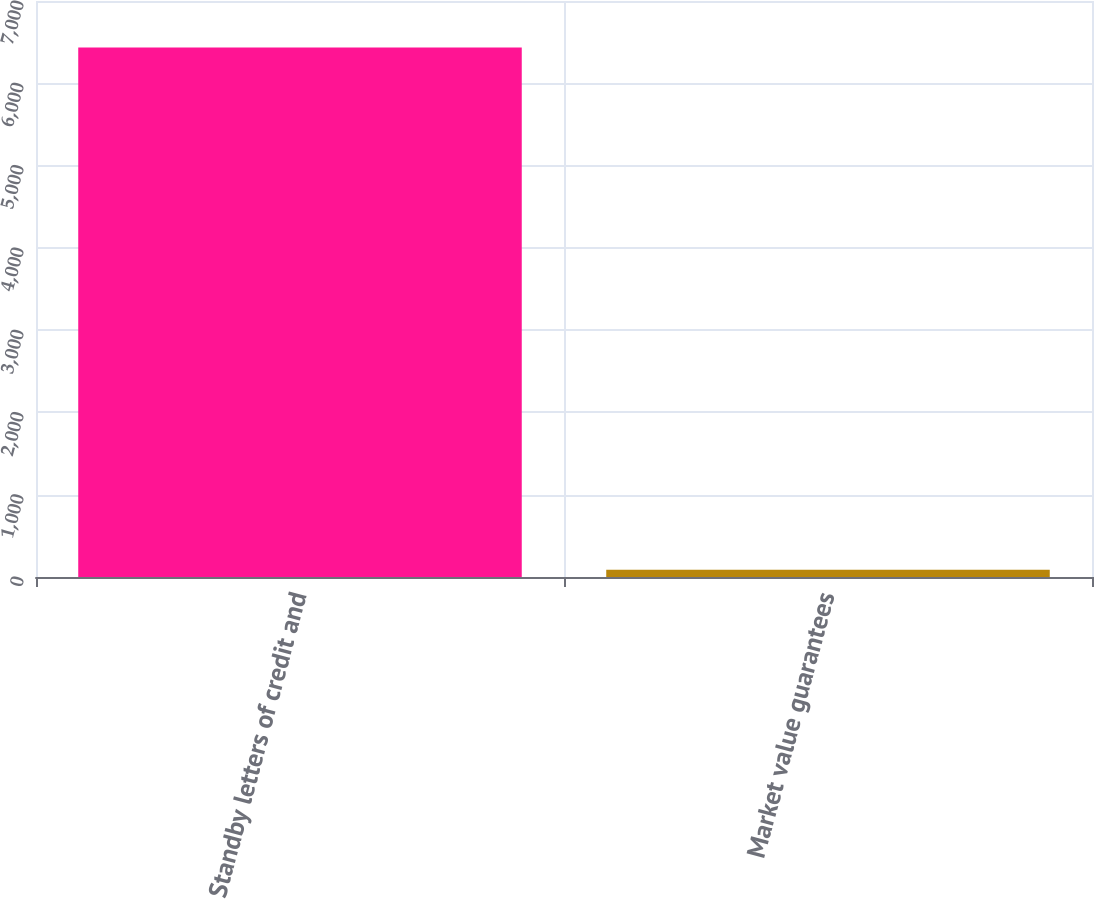<chart> <loc_0><loc_0><loc_500><loc_500><bar_chart><fcel>Standby letters of credit and<fcel>Market value guarantees<nl><fcel>6434<fcel>88<nl></chart> 